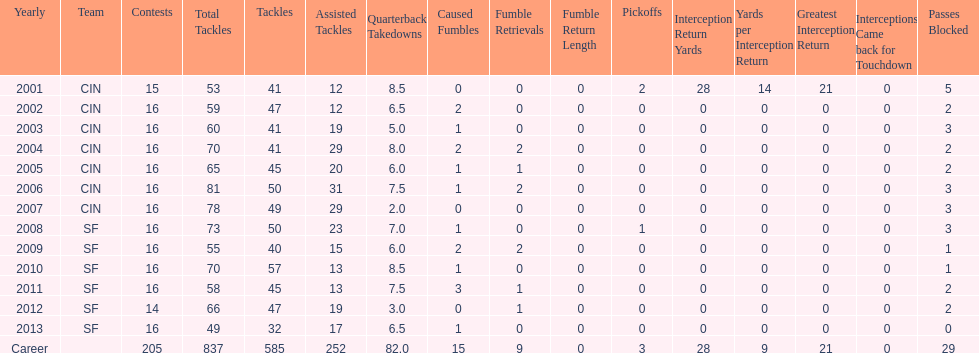How many consecutive seasons has he played sixteen games? 10. 